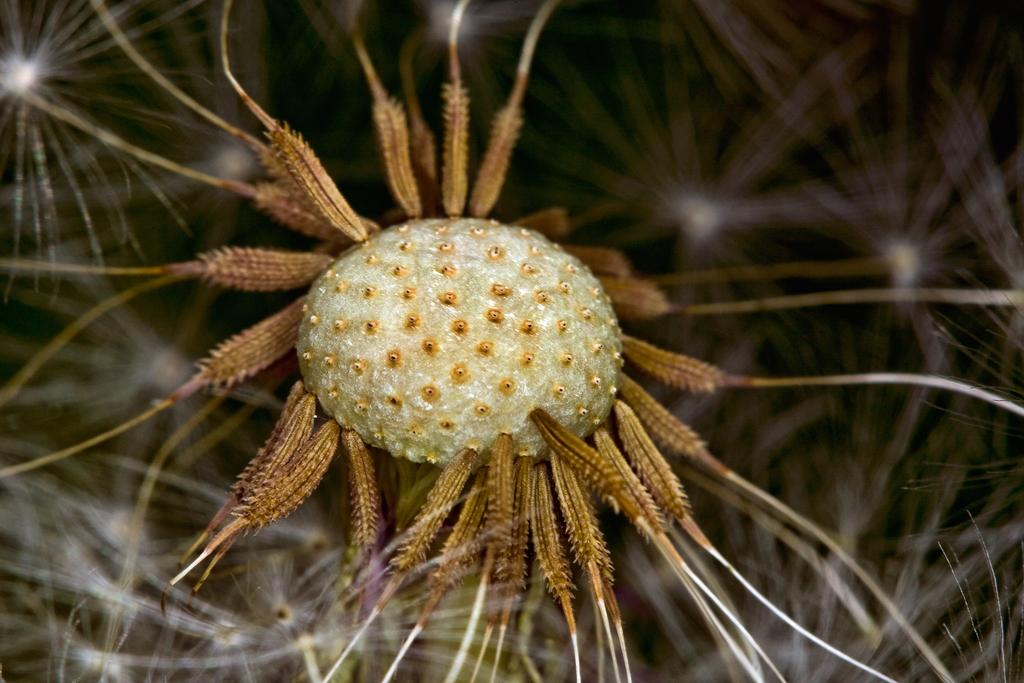What type of living organisms can be seen in the image? Plants and mushrooms are visible in the image. What type of pies are being served on the tongue in the image? There is no tongue or pies present in the image; it features plants and mushrooms. How many pizzas are visible on the plants in the image? There are no pizzas present in the image; it features plants and mushrooms. 